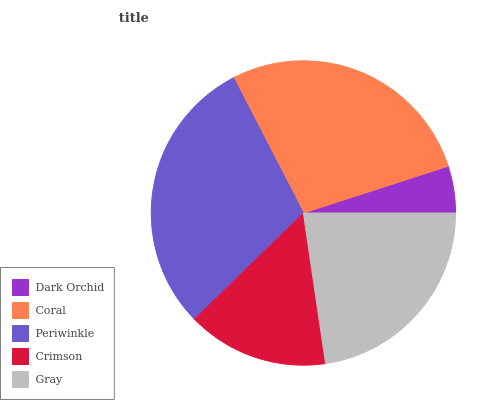Is Dark Orchid the minimum?
Answer yes or no. Yes. Is Periwinkle the maximum?
Answer yes or no. Yes. Is Coral the minimum?
Answer yes or no. No. Is Coral the maximum?
Answer yes or no. No. Is Coral greater than Dark Orchid?
Answer yes or no. Yes. Is Dark Orchid less than Coral?
Answer yes or no. Yes. Is Dark Orchid greater than Coral?
Answer yes or no. No. Is Coral less than Dark Orchid?
Answer yes or no. No. Is Gray the high median?
Answer yes or no. Yes. Is Gray the low median?
Answer yes or no. Yes. Is Periwinkle the high median?
Answer yes or no. No. Is Dark Orchid the low median?
Answer yes or no. No. 